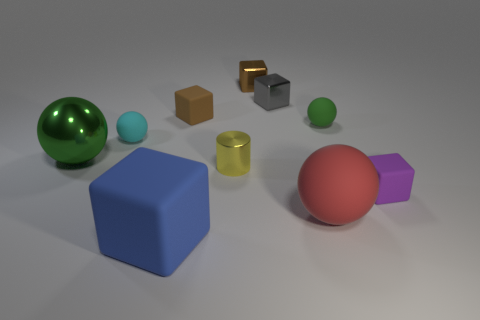Subtract 1 blocks. How many blocks are left? 4 Subtract all small brown metal cubes. How many cubes are left? 4 Subtract all yellow blocks. Subtract all brown spheres. How many blocks are left? 5 Subtract all spheres. How many objects are left? 6 Subtract all shiny cylinders. Subtract all yellow cylinders. How many objects are left? 8 Add 3 small matte balls. How many small matte balls are left? 5 Add 2 tiny yellow cubes. How many tiny yellow cubes exist? 2 Subtract 0 red cylinders. How many objects are left? 10 